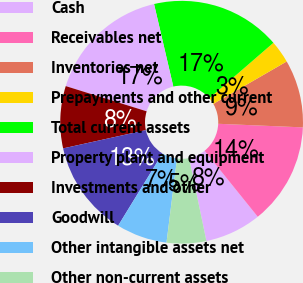Convert chart. <chart><loc_0><loc_0><loc_500><loc_500><pie_chart><fcel>Cash<fcel>Receivables net<fcel>Inventories net<fcel>Prepayments and other current<fcel>Total current assets<fcel>Property plant and equipment<fcel>Investments and other<fcel>Goodwill<fcel>Other intangible assets net<fcel>Other non-current assets<nl><fcel>7.52%<fcel>13.53%<fcel>9.02%<fcel>3.01%<fcel>17.29%<fcel>16.54%<fcel>8.27%<fcel>12.78%<fcel>6.77%<fcel>5.26%<nl></chart> 